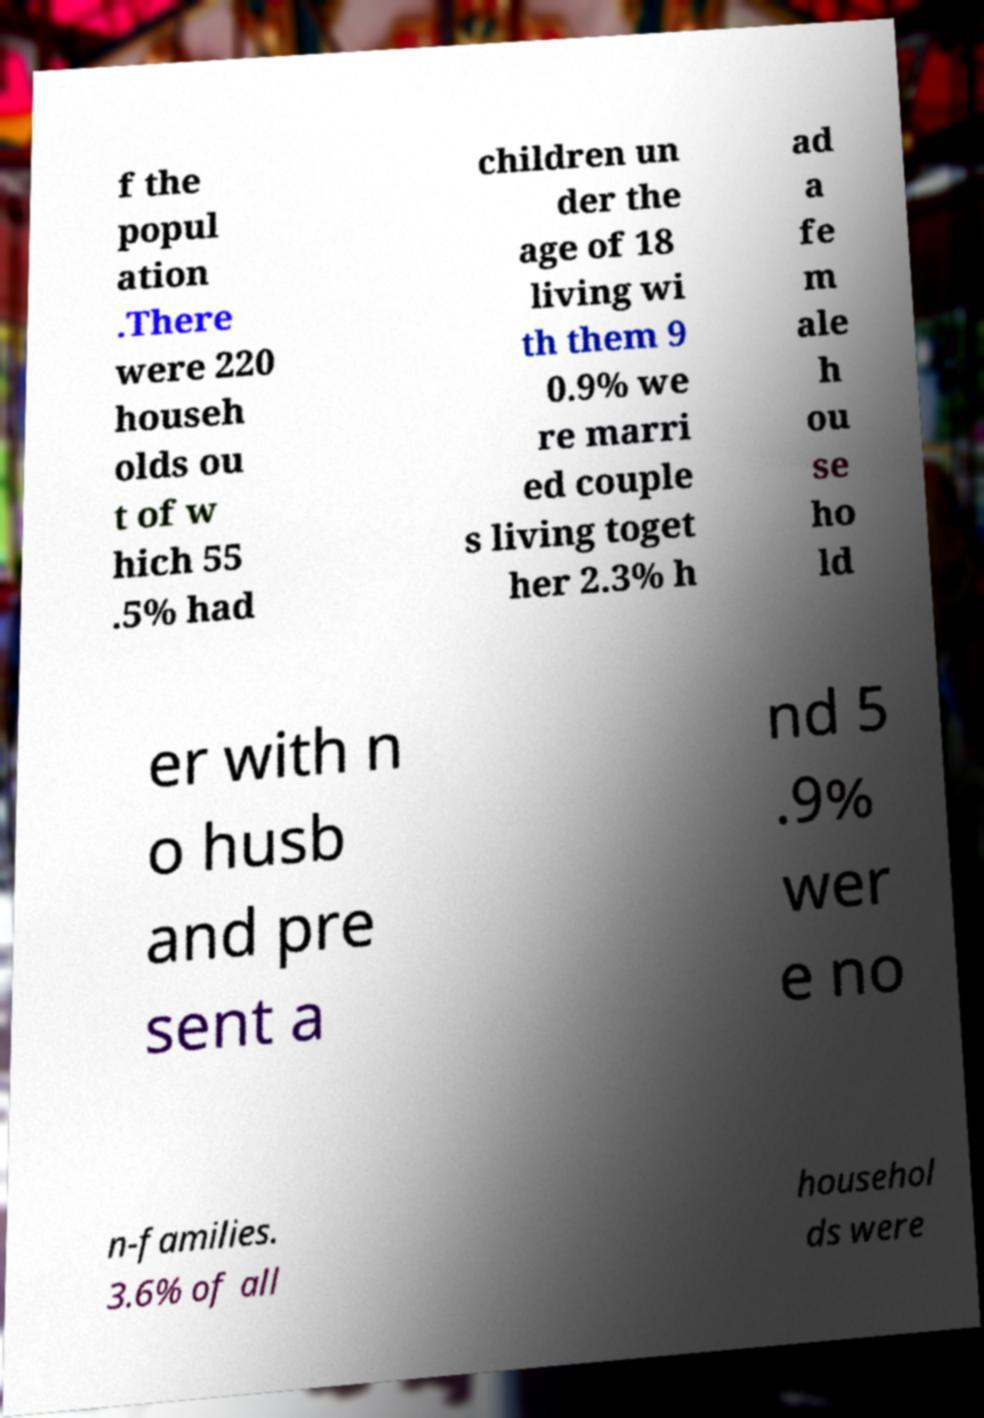Could you assist in decoding the text presented in this image and type it out clearly? f the popul ation .There were 220 househ olds ou t of w hich 55 .5% had children un der the age of 18 living wi th them 9 0.9% we re marri ed couple s living toget her 2.3% h ad a fe m ale h ou se ho ld er with n o husb and pre sent a nd 5 .9% wer e no n-families. 3.6% of all househol ds were 